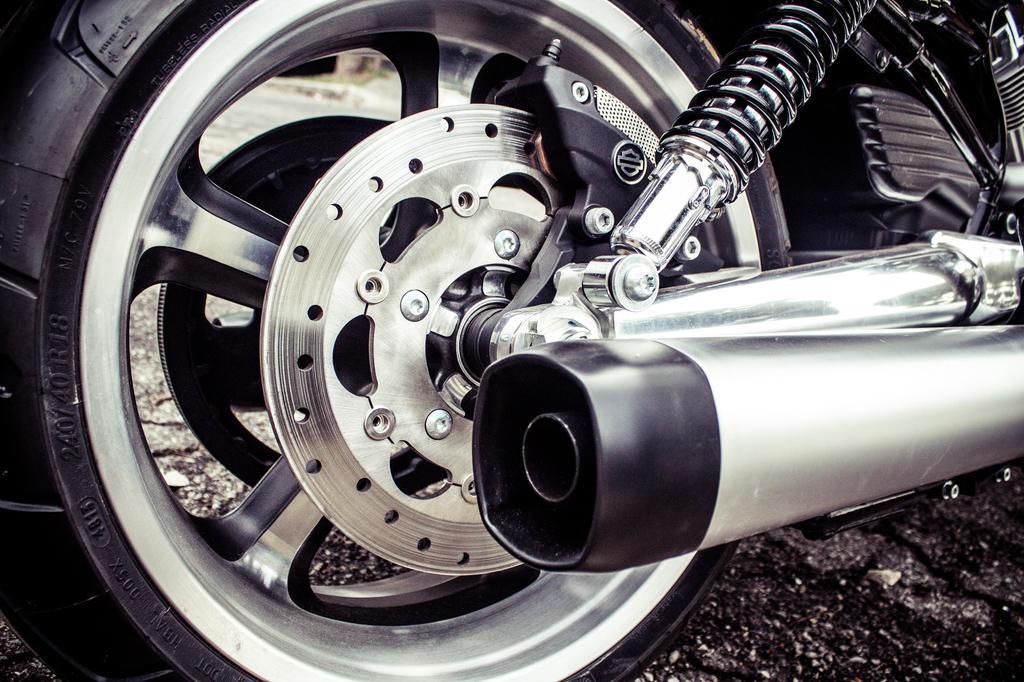Could you give a brief overview of what you see in this image? In this image there is a bike. 